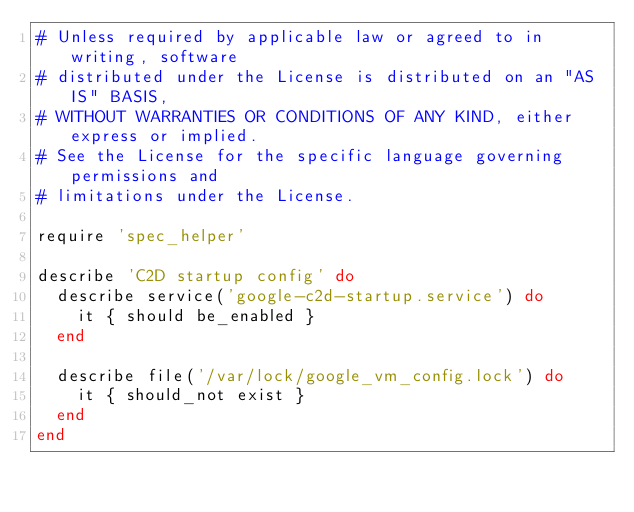<code> <loc_0><loc_0><loc_500><loc_500><_Ruby_># Unless required by applicable law or agreed to in writing, software
# distributed under the License is distributed on an "AS IS" BASIS,
# WITHOUT WARRANTIES OR CONDITIONS OF ANY KIND, either express or implied.
# See the License for the specific language governing permissions and
# limitations under the License.

require 'spec_helper'

describe 'C2D startup config' do
  describe service('google-c2d-startup.service') do
    it { should be_enabled }
  end

  describe file('/var/lock/google_vm_config.lock') do
    it { should_not exist }
  end
end
</code> 